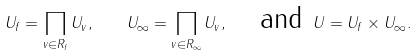Convert formula to latex. <formula><loc_0><loc_0><loc_500><loc_500>U _ { f } = \prod _ { v \in R _ { f } } U _ { v } , \quad U _ { \infty } = \prod _ { v \in R _ { \infty } } U _ { v } , \quad \text {and } U = U _ { f } \times U _ { \infty } .</formula> 